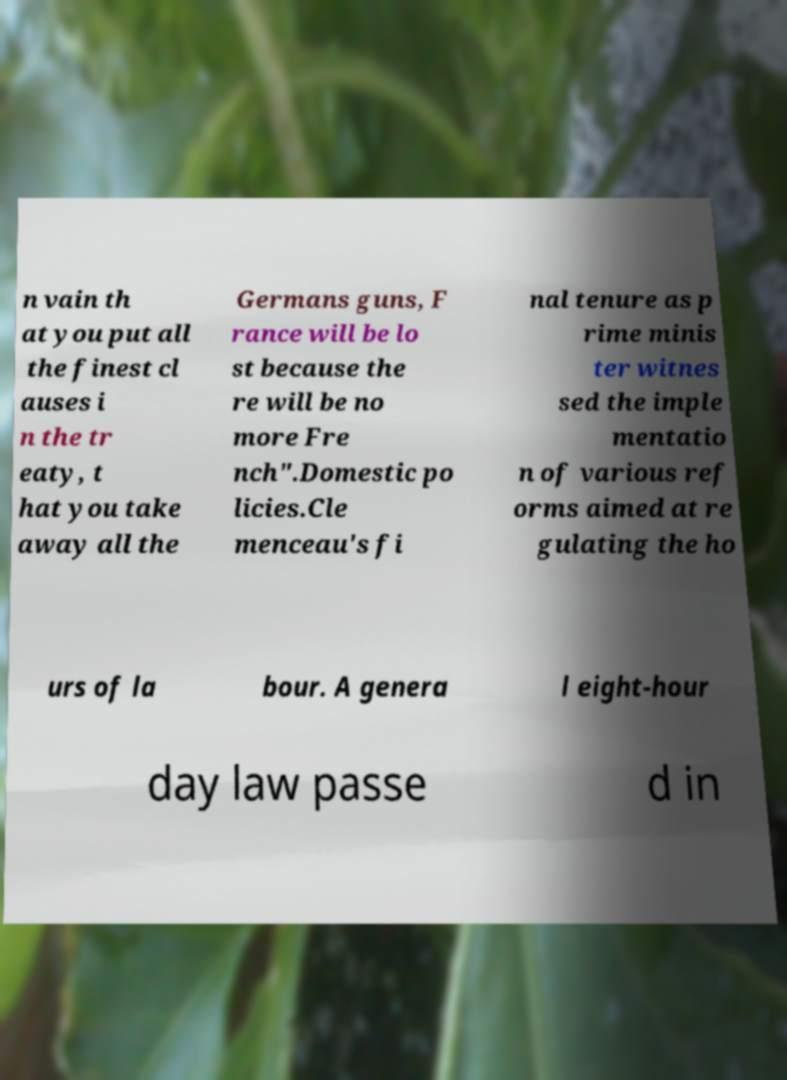Please read and relay the text visible in this image. What does it say? n vain th at you put all the finest cl auses i n the tr eaty, t hat you take away all the Germans guns, F rance will be lo st because the re will be no more Fre nch".Domestic po licies.Cle menceau's fi nal tenure as p rime minis ter witnes sed the imple mentatio n of various ref orms aimed at re gulating the ho urs of la bour. A genera l eight-hour day law passe d in 